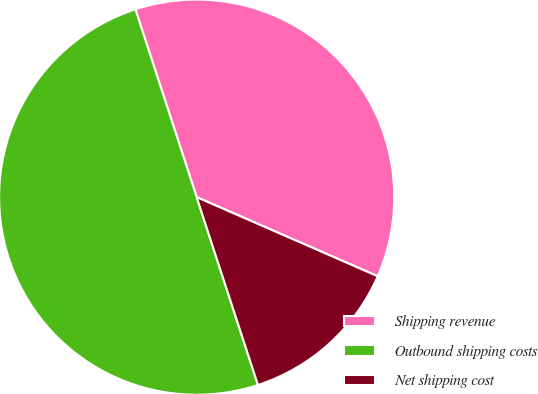<chart> <loc_0><loc_0><loc_500><loc_500><pie_chart><fcel>Shipping revenue<fcel>Outbound shipping costs<fcel>Net shipping cost<nl><fcel>36.58%<fcel>50.0%<fcel>13.42%<nl></chart> 